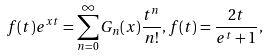Convert formula to latex. <formula><loc_0><loc_0><loc_500><loc_500>f ( t ) e ^ { x t } = \sum _ { n = 0 } ^ { \infty } G _ { n } ( x ) \frac { t ^ { n } } { n ! } , f ( t ) = \frac { 2 t } { e ^ { t } + 1 } ,</formula> 